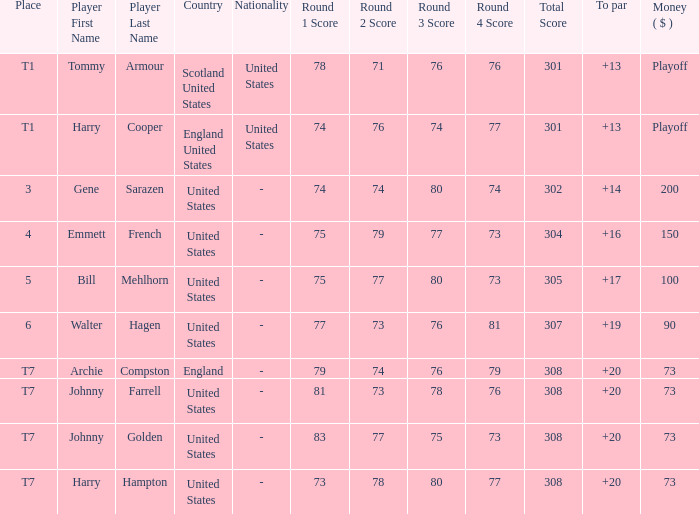When the sum is $200, where does the united states rank? 3.0. 